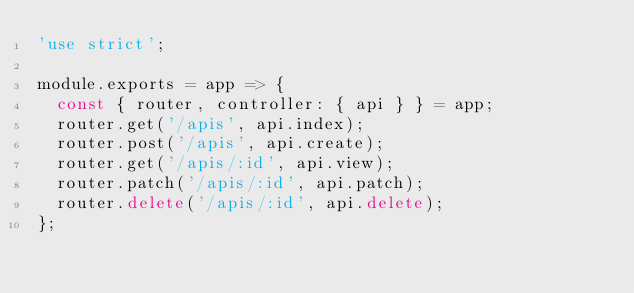Convert code to text. <code><loc_0><loc_0><loc_500><loc_500><_JavaScript_>'use strict';

module.exports = app => {
  const { router, controller: { api } } = app;
  router.get('/apis', api.index);
  router.post('/apis', api.create);
  router.get('/apis/:id', api.view);
  router.patch('/apis/:id', api.patch);
  router.delete('/apis/:id', api.delete);
};

</code> 